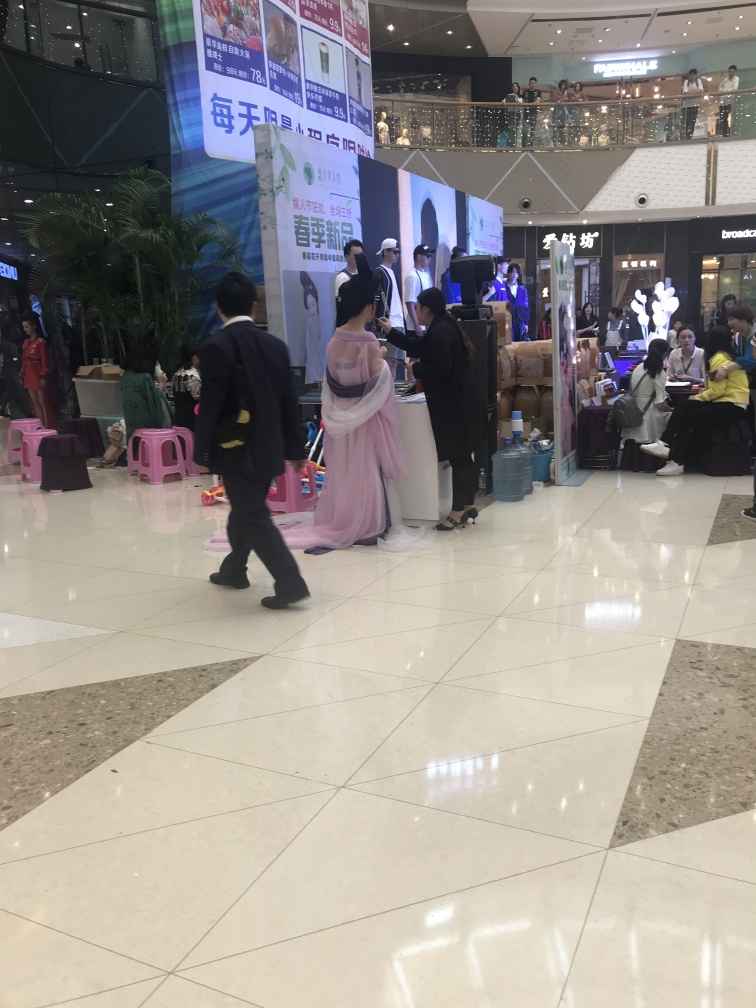Can you describe what is happening in the image? The image captures what appears to be an indoor event at a shopping mall, with several booths and individuals engaged in various activities, likely a promotional or sales event as suggested by the banners and stands. What can you infer about the atmosphere of the event? The atmosphere seems to be bustling and informative, as there are clusters of people interacting with the promotional booths, and the onlookers on the upper floor add a sense of a crowd being drawn to the event. 